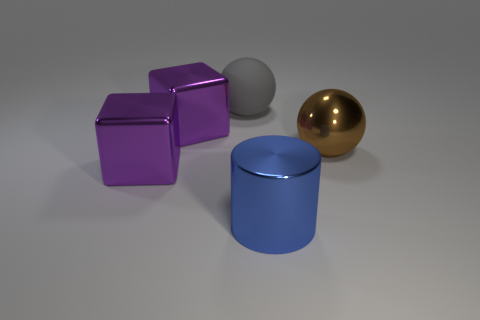What materials do these objects appear to be made of? The objects seem to be computer-generated and are designed to imitate different materials. The cylinder and the cube on the left appear to have a matte finish possibly suggesting a plastic or painted wood surface, while the shiny sphere and cube on the right look like they could be representing a polished metal material. 